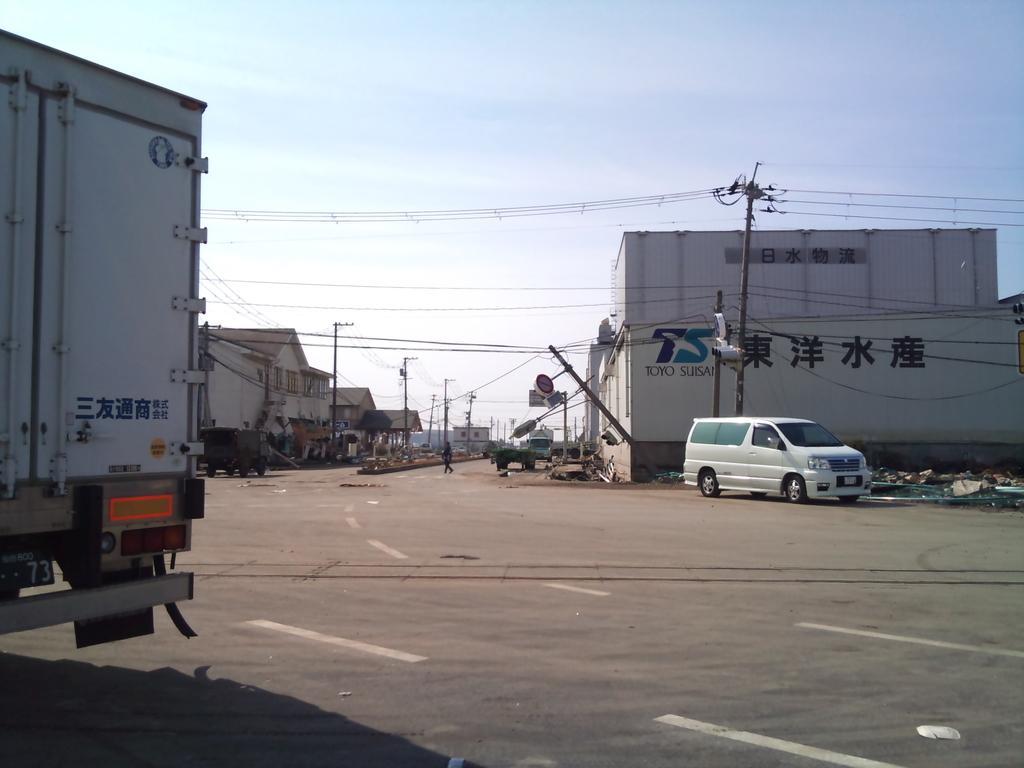Could you give a brief overview of what you see in this image? In this picture we can see vehicles and a person walking on the road, buildings with windows, poles, wires and in the background we can see the sky. 